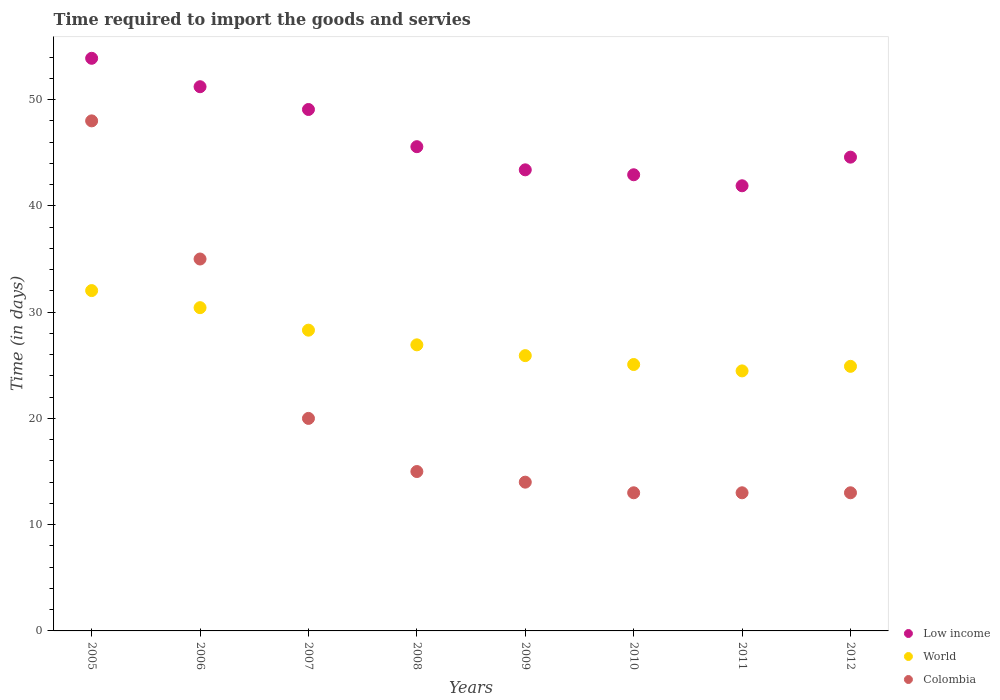Is the number of dotlines equal to the number of legend labels?
Give a very brief answer. Yes. What is the number of days required to import the goods and services in World in 2007?
Give a very brief answer. 28.3. Across all years, what is the maximum number of days required to import the goods and services in World?
Your response must be concise. 32.03. Across all years, what is the minimum number of days required to import the goods and services in Colombia?
Your answer should be compact. 13. In which year was the number of days required to import the goods and services in Colombia maximum?
Your answer should be compact. 2005. In which year was the number of days required to import the goods and services in Colombia minimum?
Make the answer very short. 2010. What is the total number of days required to import the goods and services in Colombia in the graph?
Provide a succinct answer. 171. What is the difference between the number of days required to import the goods and services in Low income in 2005 and that in 2006?
Offer a terse response. 2.67. What is the difference between the number of days required to import the goods and services in World in 2005 and the number of days required to import the goods and services in Colombia in 2008?
Your answer should be very brief. 17.03. What is the average number of days required to import the goods and services in World per year?
Ensure brevity in your answer.  27.25. In the year 2010, what is the difference between the number of days required to import the goods and services in Colombia and number of days required to import the goods and services in Low income?
Your response must be concise. -29.93. In how many years, is the number of days required to import the goods and services in World greater than 30 days?
Offer a very short reply. 2. What is the ratio of the number of days required to import the goods and services in Low income in 2006 to that in 2010?
Your answer should be compact. 1.19. What is the difference between the highest and the lowest number of days required to import the goods and services in World?
Your answer should be compact. 7.56. In how many years, is the number of days required to import the goods and services in Colombia greater than the average number of days required to import the goods and services in Colombia taken over all years?
Offer a very short reply. 2. Is the sum of the number of days required to import the goods and services in Low income in 2008 and 2009 greater than the maximum number of days required to import the goods and services in Colombia across all years?
Your response must be concise. Yes. Is the number of days required to import the goods and services in Colombia strictly less than the number of days required to import the goods and services in Low income over the years?
Provide a succinct answer. Yes. What is the difference between two consecutive major ticks on the Y-axis?
Offer a very short reply. 10. Are the values on the major ticks of Y-axis written in scientific E-notation?
Keep it short and to the point. No. Does the graph contain grids?
Provide a short and direct response. No. How many legend labels are there?
Ensure brevity in your answer.  3. What is the title of the graph?
Provide a succinct answer. Time required to import the goods and servies. What is the label or title of the Y-axis?
Offer a very short reply. Time (in days). What is the Time (in days) of Low income in 2005?
Make the answer very short. 53.89. What is the Time (in days) of World in 2005?
Provide a short and direct response. 32.03. What is the Time (in days) of Low income in 2006?
Ensure brevity in your answer.  51.21. What is the Time (in days) in World in 2006?
Offer a very short reply. 30.42. What is the Time (in days) of Colombia in 2006?
Provide a short and direct response. 35. What is the Time (in days) of Low income in 2007?
Provide a short and direct response. 49.07. What is the Time (in days) of World in 2007?
Your answer should be very brief. 28.3. What is the Time (in days) in Low income in 2008?
Provide a short and direct response. 45.57. What is the Time (in days) of World in 2008?
Provide a short and direct response. 26.92. What is the Time (in days) in Low income in 2009?
Give a very brief answer. 43.39. What is the Time (in days) in World in 2009?
Give a very brief answer. 25.91. What is the Time (in days) in Colombia in 2009?
Offer a terse response. 14. What is the Time (in days) of Low income in 2010?
Provide a succinct answer. 42.93. What is the Time (in days) of World in 2010?
Your answer should be very brief. 25.07. What is the Time (in days) of Colombia in 2010?
Provide a succinct answer. 13. What is the Time (in days) in Low income in 2011?
Offer a terse response. 41.89. What is the Time (in days) in World in 2011?
Give a very brief answer. 24.47. What is the Time (in days) in Low income in 2012?
Your answer should be very brief. 44.59. What is the Time (in days) of World in 2012?
Provide a succinct answer. 24.9. Across all years, what is the maximum Time (in days) of Low income?
Keep it short and to the point. 53.89. Across all years, what is the maximum Time (in days) of World?
Give a very brief answer. 32.03. Across all years, what is the minimum Time (in days) of Low income?
Keep it short and to the point. 41.89. Across all years, what is the minimum Time (in days) of World?
Your answer should be very brief. 24.47. What is the total Time (in days) in Low income in the graph?
Offer a very short reply. 372.55. What is the total Time (in days) in World in the graph?
Your answer should be very brief. 218.02. What is the total Time (in days) of Colombia in the graph?
Provide a short and direct response. 171. What is the difference between the Time (in days) in Low income in 2005 and that in 2006?
Offer a terse response. 2.67. What is the difference between the Time (in days) of World in 2005 and that in 2006?
Provide a succinct answer. 1.61. What is the difference between the Time (in days) in Low income in 2005 and that in 2007?
Make the answer very short. 4.82. What is the difference between the Time (in days) in World in 2005 and that in 2007?
Your answer should be compact. 3.72. What is the difference between the Time (in days) of Colombia in 2005 and that in 2007?
Your answer should be very brief. 28. What is the difference between the Time (in days) in Low income in 2005 and that in 2008?
Your answer should be very brief. 8.32. What is the difference between the Time (in days) in World in 2005 and that in 2008?
Your response must be concise. 5.11. What is the difference between the Time (in days) in Low income in 2005 and that in 2009?
Your response must be concise. 10.5. What is the difference between the Time (in days) of World in 2005 and that in 2009?
Keep it short and to the point. 6.12. What is the difference between the Time (in days) in Colombia in 2005 and that in 2009?
Offer a terse response. 34. What is the difference between the Time (in days) in Low income in 2005 and that in 2010?
Make the answer very short. 10.96. What is the difference between the Time (in days) of World in 2005 and that in 2010?
Provide a short and direct response. 6.96. What is the difference between the Time (in days) in Colombia in 2005 and that in 2010?
Offer a very short reply. 35. What is the difference between the Time (in days) in Low income in 2005 and that in 2011?
Your answer should be compact. 12. What is the difference between the Time (in days) of World in 2005 and that in 2011?
Your answer should be very brief. 7.56. What is the difference between the Time (in days) in Colombia in 2005 and that in 2011?
Keep it short and to the point. 35. What is the difference between the Time (in days) in Low income in 2005 and that in 2012?
Ensure brevity in your answer.  9.3. What is the difference between the Time (in days) of World in 2005 and that in 2012?
Offer a terse response. 7.13. What is the difference between the Time (in days) of Colombia in 2005 and that in 2012?
Ensure brevity in your answer.  35. What is the difference between the Time (in days) in Low income in 2006 and that in 2007?
Give a very brief answer. 2.14. What is the difference between the Time (in days) of World in 2006 and that in 2007?
Provide a short and direct response. 2.12. What is the difference between the Time (in days) of Colombia in 2006 and that in 2007?
Provide a succinct answer. 15. What is the difference between the Time (in days) in Low income in 2006 and that in 2008?
Offer a terse response. 5.64. What is the difference between the Time (in days) in World in 2006 and that in 2008?
Give a very brief answer. 3.5. What is the difference between the Time (in days) of Colombia in 2006 and that in 2008?
Provide a succinct answer. 20. What is the difference between the Time (in days) of Low income in 2006 and that in 2009?
Your answer should be compact. 7.82. What is the difference between the Time (in days) in World in 2006 and that in 2009?
Provide a succinct answer. 4.51. What is the difference between the Time (in days) of Colombia in 2006 and that in 2009?
Provide a succinct answer. 21. What is the difference between the Time (in days) in Low income in 2006 and that in 2010?
Ensure brevity in your answer.  8.29. What is the difference between the Time (in days) of World in 2006 and that in 2010?
Keep it short and to the point. 5.35. What is the difference between the Time (in days) of Low income in 2006 and that in 2011?
Give a very brief answer. 9.32. What is the difference between the Time (in days) in World in 2006 and that in 2011?
Give a very brief answer. 5.95. What is the difference between the Time (in days) in Low income in 2006 and that in 2012?
Your response must be concise. 6.63. What is the difference between the Time (in days) in World in 2006 and that in 2012?
Ensure brevity in your answer.  5.52. What is the difference between the Time (in days) of Colombia in 2006 and that in 2012?
Offer a very short reply. 22. What is the difference between the Time (in days) of Low income in 2007 and that in 2008?
Your response must be concise. 3.5. What is the difference between the Time (in days) of World in 2007 and that in 2008?
Your answer should be very brief. 1.38. What is the difference between the Time (in days) in Colombia in 2007 and that in 2008?
Your response must be concise. 5. What is the difference between the Time (in days) in Low income in 2007 and that in 2009?
Keep it short and to the point. 5.68. What is the difference between the Time (in days) of World in 2007 and that in 2009?
Provide a succinct answer. 2.4. What is the difference between the Time (in days) of Colombia in 2007 and that in 2009?
Provide a succinct answer. 6. What is the difference between the Time (in days) of Low income in 2007 and that in 2010?
Keep it short and to the point. 6.14. What is the difference between the Time (in days) in World in 2007 and that in 2010?
Your answer should be very brief. 3.23. What is the difference between the Time (in days) of Low income in 2007 and that in 2011?
Provide a short and direct response. 7.18. What is the difference between the Time (in days) in World in 2007 and that in 2011?
Your response must be concise. 3.83. What is the difference between the Time (in days) in Low income in 2007 and that in 2012?
Ensure brevity in your answer.  4.49. What is the difference between the Time (in days) of World in 2007 and that in 2012?
Ensure brevity in your answer.  3.4. What is the difference between the Time (in days) in Colombia in 2007 and that in 2012?
Your response must be concise. 7. What is the difference between the Time (in days) of Low income in 2008 and that in 2009?
Keep it short and to the point. 2.18. What is the difference between the Time (in days) in World in 2008 and that in 2009?
Provide a succinct answer. 1.02. What is the difference between the Time (in days) in Colombia in 2008 and that in 2009?
Provide a succinct answer. 1. What is the difference between the Time (in days) of Low income in 2008 and that in 2010?
Offer a terse response. 2.64. What is the difference between the Time (in days) in World in 2008 and that in 2010?
Your answer should be very brief. 1.85. What is the difference between the Time (in days) in Low income in 2008 and that in 2011?
Offer a very short reply. 3.68. What is the difference between the Time (in days) in World in 2008 and that in 2011?
Ensure brevity in your answer.  2.45. What is the difference between the Time (in days) in Colombia in 2008 and that in 2011?
Your answer should be very brief. 2. What is the difference between the Time (in days) of Low income in 2008 and that in 2012?
Ensure brevity in your answer.  0.99. What is the difference between the Time (in days) in World in 2008 and that in 2012?
Keep it short and to the point. 2.02. What is the difference between the Time (in days) in Colombia in 2008 and that in 2012?
Give a very brief answer. 2. What is the difference between the Time (in days) of Low income in 2009 and that in 2010?
Your response must be concise. 0.46. What is the difference between the Time (in days) of World in 2009 and that in 2010?
Your answer should be very brief. 0.84. What is the difference between the Time (in days) of Colombia in 2009 and that in 2010?
Keep it short and to the point. 1. What is the difference between the Time (in days) in World in 2009 and that in 2011?
Your response must be concise. 1.44. What is the difference between the Time (in days) in Colombia in 2009 and that in 2011?
Offer a very short reply. 1. What is the difference between the Time (in days) in Low income in 2009 and that in 2012?
Provide a short and direct response. -1.19. What is the difference between the Time (in days) of World in 2009 and that in 2012?
Provide a succinct answer. 1.01. What is the difference between the Time (in days) of Low income in 2010 and that in 2011?
Provide a succinct answer. 1.04. What is the difference between the Time (in days) of World in 2010 and that in 2011?
Provide a short and direct response. 0.6. What is the difference between the Time (in days) of Colombia in 2010 and that in 2011?
Offer a very short reply. 0. What is the difference between the Time (in days) of Low income in 2010 and that in 2012?
Give a very brief answer. -1.66. What is the difference between the Time (in days) in World in 2010 and that in 2012?
Offer a terse response. 0.17. What is the difference between the Time (in days) in Low income in 2011 and that in 2012?
Ensure brevity in your answer.  -2.69. What is the difference between the Time (in days) of World in 2011 and that in 2012?
Your response must be concise. -0.43. What is the difference between the Time (in days) in Colombia in 2011 and that in 2012?
Provide a short and direct response. 0. What is the difference between the Time (in days) of Low income in 2005 and the Time (in days) of World in 2006?
Your answer should be compact. 23.47. What is the difference between the Time (in days) in Low income in 2005 and the Time (in days) in Colombia in 2006?
Give a very brief answer. 18.89. What is the difference between the Time (in days) of World in 2005 and the Time (in days) of Colombia in 2006?
Give a very brief answer. -2.97. What is the difference between the Time (in days) of Low income in 2005 and the Time (in days) of World in 2007?
Give a very brief answer. 25.59. What is the difference between the Time (in days) in Low income in 2005 and the Time (in days) in Colombia in 2007?
Make the answer very short. 33.89. What is the difference between the Time (in days) in World in 2005 and the Time (in days) in Colombia in 2007?
Ensure brevity in your answer.  12.03. What is the difference between the Time (in days) of Low income in 2005 and the Time (in days) of World in 2008?
Offer a terse response. 26.97. What is the difference between the Time (in days) of Low income in 2005 and the Time (in days) of Colombia in 2008?
Offer a very short reply. 38.89. What is the difference between the Time (in days) in World in 2005 and the Time (in days) in Colombia in 2008?
Keep it short and to the point. 17.03. What is the difference between the Time (in days) of Low income in 2005 and the Time (in days) of World in 2009?
Your response must be concise. 27.98. What is the difference between the Time (in days) of Low income in 2005 and the Time (in days) of Colombia in 2009?
Your response must be concise. 39.89. What is the difference between the Time (in days) of World in 2005 and the Time (in days) of Colombia in 2009?
Offer a very short reply. 18.03. What is the difference between the Time (in days) in Low income in 2005 and the Time (in days) in World in 2010?
Provide a succinct answer. 28.82. What is the difference between the Time (in days) in Low income in 2005 and the Time (in days) in Colombia in 2010?
Give a very brief answer. 40.89. What is the difference between the Time (in days) in World in 2005 and the Time (in days) in Colombia in 2010?
Offer a very short reply. 19.03. What is the difference between the Time (in days) in Low income in 2005 and the Time (in days) in World in 2011?
Provide a succinct answer. 29.42. What is the difference between the Time (in days) of Low income in 2005 and the Time (in days) of Colombia in 2011?
Offer a terse response. 40.89. What is the difference between the Time (in days) in World in 2005 and the Time (in days) in Colombia in 2011?
Offer a very short reply. 19.03. What is the difference between the Time (in days) of Low income in 2005 and the Time (in days) of World in 2012?
Give a very brief answer. 28.99. What is the difference between the Time (in days) in Low income in 2005 and the Time (in days) in Colombia in 2012?
Provide a succinct answer. 40.89. What is the difference between the Time (in days) in World in 2005 and the Time (in days) in Colombia in 2012?
Keep it short and to the point. 19.03. What is the difference between the Time (in days) in Low income in 2006 and the Time (in days) in World in 2007?
Your answer should be very brief. 22.91. What is the difference between the Time (in days) in Low income in 2006 and the Time (in days) in Colombia in 2007?
Provide a succinct answer. 31.21. What is the difference between the Time (in days) of World in 2006 and the Time (in days) of Colombia in 2007?
Provide a short and direct response. 10.42. What is the difference between the Time (in days) in Low income in 2006 and the Time (in days) in World in 2008?
Your response must be concise. 24.29. What is the difference between the Time (in days) of Low income in 2006 and the Time (in days) of Colombia in 2008?
Offer a terse response. 36.21. What is the difference between the Time (in days) of World in 2006 and the Time (in days) of Colombia in 2008?
Offer a very short reply. 15.42. What is the difference between the Time (in days) in Low income in 2006 and the Time (in days) in World in 2009?
Provide a short and direct response. 25.31. What is the difference between the Time (in days) of Low income in 2006 and the Time (in days) of Colombia in 2009?
Provide a succinct answer. 37.21. What is the difference between the Time (in days) in World in 2006 and the Time (in days) in Colombia in 2009?
Your answer should be compact. 16.42. What is the difference between the Time (in days) of Low income in 2006 and the Time (in days) of World in 2010?
Provide a short and direct response. 26.14. What is the difference between the Time (in days) of Low income in 2006 and the Time (in days) of Colombia in 2010?
Make the answer very short. 38.21. What is the difference between the Time (in days) in World in 2006 and the Time (in days) in Colombia in 2010?
Provide a succinct answer. 17.42. What is the difference between the Time (in days) of Low income in 2006 and the Time (in days) of World in 2011?
Your response must be concise. 26.74. What is the difference between the Time (in days) of Low income in 2006 and the Time (in days) of Colombia in 2011?
Give a very brief answer. 38.21. What is the difference between the Time (in days) of World in 2006 and the Time (in days) of Colombia in 2011?
Your answer should be very brief. 17.42. What is the difference between the Time (in days) in Low income in 2006 and the Time (in days) in World in 2012?
Provide a short and direct response. 26.31. What is the difference between the Time (in days) of Low income in 2006 and the Time (in days) of Colombia in 2012?
Offer a very short reply. 38.21. What is the difference between the Time (in days) in World in 2006 and the Time (in days) in Colombia in 2012?
Your response must be concise. 17.42. What is the difference between the Time (in days) of Low income in 2007 and the Time (in days) of World in 2008?
Ensure brevity in your answer.  22.15. What is the difference between the Time (in days) of Low income in 2007 and the Time (in days) of Colombia in 2008?
Give a very brief answer. 34.07. What is the difference between the Time (in days) in World in 2007 and the Time (in days) in Colombia in 2008?
Offer a terse response. 13.3. What is the difference between the Time (in days) of Low income in 2007 and the Time (in days) of World in 2009?
Keep it short and to the point. 23.16. What is the difference between the Time (in days) of Low income in 2007 and the Time (in days) of Colombia in 2009?
Ensure brevity in your answer.  35.07. What is the difference between the Time (in days) of World in 2007 and the Time (in days) of Colombia in 2009?
Ensure brevity in your answer.  14.3. What is the difference between the Time (in days) in Low income in 2007 and the Time (in days) in World in 2010?
Ensure brevity in your answer.  24. What is the difference between the Time (in days) in Low income in 2007 and the Time (in days) in Colombia in 2010?
Make the answer very short. 36.07. What is the difference between the Time (in days) of World in 2007 and the Time (in days) of Colombia in 2010?
Keep it short and to the point. 15.3. What is the difference between the Time (in days) of Low income in 2007 and the Time (in days) of World in 2011?
Provide a short and direct response. 24.6. What is the difference between the Time (in days) of Low income in 2007 and the Time (in days) of Colombia in 2011?
Your response must be concise. 36.07. What is the difference between the Time (in days) in World in 2007 and the Time (in days) in Colombia in 2011?
Your answer should be compact. 15.3. What is the difference between the Time (in days) of Low income in 2007 and the Time (in days) of World in 2012?
Make the answer very short. 24.17. What is the difference between the Time (in days) of Low income in 2007 and the Time (in days) of Colombia in 2012?
Your response must be concise. 36.07. What is the difference between the Time (in days) in World in 2007 and the Time (in days) in Colombia in 2012?
Provide a succinct answer. 15.3. What is the difference between the Time (in days) in Low income in 2008 and the Time (in days) in World in 2009?
Keep it short and to the point. 19.66. What is the difference between the Time (in days) in Low income in 2008 and the Time (in days) in Colombia in 2009?
Keep it short and to the point. 31.57. What is the difference between the Time (in days) in World in 2008 and the Time (in days) in Colombia in 2009?
Give a very brief answer. 12.92. What is the difference between the Time (in days) in Low income in 2008 and the Time (in days) in World in 2010?
Provide a succinct answer. 20.5. What is the difference between the Time (in days) of Low income in 2008 and the Time (in days) of Colombia in 2010?
Your answer should be compact. 32.57. What is the difference between the Time (in days) in World in 2008 and the Time (in days) in Colombia in 2010?
Ensure brevity in your answer.  13.92. What is the difference between the Time (in days) in Low income in 2008 and the Time (in days) in World in 2011?
Provide a short and direct response. 21.1. What is the difference between the Time (in days) in Low income in 2008 and the Time (in days) in Colombia in 2011?
Ensure brevity in your answer.  32.57. What is the difference between the Time (in days) of World in 2008 and the Time (in days) of Colombia in 2011?
Ensure brevity in your answer.  13.92. What is the difference between the Time (in days) of Low income in 2008 and the Time (in days) of World in 2012?
Offer a very short reply. 20.67. What is the difference between the Time (in days) of Low income in 2008 and the Time (in days) of Colombia in 2012?
Your answer should be compact. 32.57. What is the difference between the Time (in days) in World in 2008 and the Time (in days) in Colombia in 2012?
Offer a very short reply. 13.92. What is the difference between the Time (in days) in Low income in 2009 and the Time (in days) in World in 2010?
Make the answer very short. 18.32. What is the difference between the Time (in days) of Low income in 2009 and the Time (in days) of Colombia in 2010?
Offer a very short reply. 30.39. What is the difference between the Time (in days) in World in 2009 and the Time (in days) in Colombia in 2010?
Your answer should be compact. 12.91. What is the difference between the Time (in days) in Low income in 2009 and the Time (in days) in World in 2011?
Ensure brevity in your answer.  18.92. What is the difference between the Time (in days) of Low income in 2009 and the Time (in days) of Colombia in 2011?
Your answer should be very brief. 30.39. What is the difference between the Time (in days) of World in 2009 and the Time (in days) of Colombia in 2011?
Your response must be concise. 12.91. What is the difference between the Time (in days) in Low income in 2009 and the Time (in days) in World in 2012?
Ensure brevity in your answer.  18.49. What is the difference between the Time (in days) in Low income in 2009 and the Time (in days) in Colombia in 2012?
Provide a short and direct response. 30.39. What is the difference between the Time (in days) of World in 2009 and the Time (in days) of Colombia in 2012?
Keep it short and to the point. 12.91. What is the difference between the Time (in days) in Low income in 2010 and the Time (in days) in World in 2011?
Offer a very short reply. 18.46. What is the difference between the Time (in days) of Low income in 2010 and the Time (in days) of Colombia in 2011?
Provide a short and direct response. 29.93. What is the difference between the Time (in days) in World in 2010 and the Time (in days) in Colombia in 2011?
Make the answer very short. 12.07. What is the difference between the Time (in days) in Low income in 2010 and the Time (in days) in World in 2012?
Your answer should be compact. 18.03. What is the difference between the Time (in days) in Low income in 2010 and the Time (in days) in Colombia in 2012?
Your response must be concise. 29.93. What is the difference between the Time (in days) in World in 2010 and the Time (in days) in Colombia in 2012?
Your answer should be very brief. 12.07. What is the difference between the Time (in days) of Low income in 2011 and the Time (in days) of World in 2012?
Offer a very short reply. 16.99. What is the difference between the Time (in days) of Low income in 2011 and the Time (in days) of Colombia in 2012?
Keep it short and to the point. 28.89. What is the difference between the Time (in days) in World in 2011 and the Time (in days) in Colombia in 2012?
Your response must be concise. 11.47. What is the average Time (in days) of Low income per year?
Provide a succinct answer. 46.57. What is the average Time (in days) in World per year?
Keep it short and to the point. 27.25. What is the average Time (in days) of Colombia per year?
Your answer should be very brief. 21.38. In the year 2005, what is the difference between the Time (in days) in Low income and Time (in days) in World?
Your answer should be very brief. 21.86. In the year 2005, what is the difference between the Time (in days) of Low income and Time (in days) of Colombia?
Your response must be concise. 5.89. In the year 2005, what is the difference between the Time (in days) in World and Time (in days) in Colombia?
Provide a succinct answer. -15.97. In the year 2006, what is the difference between the Time (in days) of Low income and Time (in days) of World?
Your response must be concise. 20.79. In the year 2006, what is the difference between the Time (in days) of Low income and Time (in days) of Colombia?
Provide a succinct answer. 16.21. In the year 2006, what is the difference between the Time (in days) in World and Time (in days) in Colombia?
Ensure brevity in your answer.  -4.58. In the year 2007, what is the difference between the Time (in days) in Low income and Time (in days) in World?
Your answer should be compact. 20.77. In the year 2007, what is the difference between the Time (in days) of Low income and Time (in days) of Colombia?
Make the answer very short. 29.07. In the year 2007, what is the difference between the Time (in days) in World and Time (in days) in Colombia?
Your answer should be very brief. 8.3. In the year 2008, what is the difference between the Time (in days) in Low income and Time (in days) in World?
Offer a terse response. 18.65. In the year 2008, what is the difference between the Time (in days) of Low income and Time (in days) of Colombia?
Offer a terse response. 30.57. In the year 2008, what is the difference between the Time (in days) of World and Time (in days) of Colombia?
Keep it short and to the point. 11.92. In the year 2009, what is the difference between the Time (in days) in Low income and Time (in days) in World?
Your answer should be very brief. 17.49. In the year 2009, what is the difference between the Time (in days) of Low income and Time (in days) of Colombia?
Ensure brevity in your answer.  29.39. In the year 2009, what is the difference between the Time (in days) in World and Time (in days) in Colombia?
Make the answer very short. 11.91. In the year 2010, what is the difference between the Time (in days) in Low income and Time (in days) in World?
Provide a short and direct response. 17.86. In the year 2010, what is the difference between the Time (in days) in Low income and Time (in days) in Colombia?
Your response must be concise. 29.93. In the year 2010, what is the difference between the Time (in days) in World and Time (in days) in Colombia?
Offer a terse response. 12.07. In the year 2011, what is the difference between the Time (in days) of Low income and Time (in days) of World?
Keep it short and to the point. 17.42. In the year 2011, what is the difference between the Time (in days) in Low income and Time (in days) in Colombia?
Provide a short and direct response. 28.89. In the year 2011, what is the difference between the Time (in days) of World and Time (in days) of Colombia?
Your answer should be compact. 11.47. In the year 2012, what is the difference between the Time (in days) of Low income and Time (in days) of World?
Your answer should be compact. 19.69. In the year 2012, what is the difference between the Time (in days) in Low income and Time (in days) in Colombia?
Your answer should be very brief. 31.59. In the year 2012, what is the difference between the Time (in days) in World and Time (in days) in Colombia?
Give a very brief answer. 11.9. What is the ratio of the Time (in days) in Low income in 2005 to that in 2006?
Your answer should be very brief. 1.05. What is the ratio of the Time (in days) in World in 2005 to that in 2006?
Your answer should be compact. 1.05. What is the ratio of the Time (in days) of Colombia in 2005 to that in 2006?
Offer a terse response. 1.37. What is the ratio of the Time (in days) of Low income in 2005 to that in 2007?
Provide a succinct answer. 1.1. What is the ratio of the Time (in days) of World in 2005 to that in 2007?
Offer a terse response. 1.13. What is the ratio of the Time (in days) of Colombia in 2005 to that in 2007?
Provide a succinct answer. 2.4. What is the ratio of the Time (in days) of Low income in 2005 to that in 2008?
Offer a terse response. 1.18. What is the ratio of the Time (in days) in World in 2005 to that in 2008?
Make the answer very short. 1.19. What is the ratio of the Time (in days) of Colombia in 2005 to that in 2008?
Ensure brevity in your answer.  3.2. What is the ratio of the Time (in days) of Low income in 2005 to that in 2009?
Offer a terse response. 1.24. What is the ratio of the Time (in days) of World in 2005 to that in 2009?
Offer a terse response. 1.24. What is the ratio of the Time (in days) of Colombia in 2005 to that in 2009?
Your response must be concise. 3.43. What is the ratio of the Time (in days) in Low income in 2005 to that in 2010?
Provide a short and direct response. 1.26. What is the ratio of the Time (in days) in World in 2005 to that in 2010?
Give a very brief answer. 1.28. What is the ratio of the Time (in days) of Colombia in 2005 to that in 2010?
Provide a short and direct response. 3.69. What is the ratio of the Time (in days) of Low income in 2005 to that in 2011?
Offer a very short reply. 1.29. What is the ratio of the Time (in days) in World in 2005 to that in 2011?
Give a very brief answer. 1.31. What is the ratio of the Time (in days) of Colombia in 2005 to that in 2011?
Ensure brevity in your answer.  3.69. What is the ratio of the Time (in days) of Low income in 2005 to that in 2012?
Your response must be concise. 1.21. What is the ratio of the Time (in days) of World in 2005 to that in 2012?
Keep it short and to the point. 1.29. What is the ratio of the Time (in days) in Colombia in 2005 to that in 2012?
Offer a very short reply. 3.69. What is the ratio of the Time (in days) of Low income in 2006 to that in 2007?
Your response must be concise. 1.04. What is the ratio of the Time (in days) in World in 2006 to that in 2007?
Keep it short and to the point. 1.07. What is the ratio of the Time (in days) in Colombia in 2006 to that in 2007?
Provide a succinct answer. 1.75. What is the ratio of the Time (in days) in Low income in 2006 to that in 2008?
Keep it short and to the point. 1.12. What is the ratio of the Time (in days) of World in 2006 to that in 2008?
Offer a terse response. 1.13. What is the ratio of the Time (in days) in Colombia in 2006 to that in 2008?
Offer a terse response. 2.33. What is the ratio of the Time (in days) in Low income in 2006 to that in 2009?
Provide a succinct answer. 1.18. What is the ratio of the Time (in days) of World in 2006 to that in 2009?
Your answer should be compact. 1.17. What is the ratio of the Time (in days) in Low income in 2006 to that in 2010?
Ensure brevity in your answer.  1.19. What is the ratio of the Time (in days) in World in 2006 to that in 2010?
Make the answer very short. 1.21. What is the ratio of the Time (in days) of Colombia in 2006 to that in 2010?
Provide a succinct answer. 2.69. What is the ratio of the Time (in days) of Low income in 2006 to that in 2011?
Your answer should be very brief. 1.22. What is the ratio of the Time (in days) of World in 2006 to that in 2011?
Offer a terse response. 1.24. What is the ratio of the Time (in days) in Colombia in 2006 to that in 2011?
Make the answer very short. 2.69. What is the ratio of the Time (in days) in Low income in 2006 to that in 2012?
Give a very brief answer. 1.15. What is the ratio of the Time (in days) of World in 2006 to that in 2012?
Give a very brief answer. 1.22. What is the ratio of the Time (in days) in Colombia in 2006 to that in 2012?
Provide a succinct answer. 2.69. What is the ratio of the Time (in days) in Low income in 2007 to that in 2008?
Your answer should be compact. 1.08. What is the ratio of the Time (in days) in World in 2007 to that in 2008?
Ensure brevity in your answer.  1.05. What is the ratio of the Time (in days) of Colombia in 2007 to that in 2008?
Keep it short and to the point. 1.33. What is the ratio of the Time (in days) of Low income in 2007 to that in 2009?
Keep it short and to the point. 1.13. What is the ratio of the Time (in days) of World in 2007 to that in 2009?
Keep it short and to the point. 1.09. What is the ratio of the Time (in days) of Colombia in 2007 to that in 2009?
Keep it short and to the point. 1.43. What is the ratio of the Time (in days) in Low income in 2007 to that in 2010?
Your answer should be very brief. 1.14. What is the ratio of the Time (in days) of World in 2007 to that in 2010?
Provide a succinct answer. 1.13. What is the ratio of the Time (in days) of Colombia in 2007 to that in 2010?
Make the answer very short. 1.54. What is the ratio of the Time (in days) in Low income in 2007 to that in 2011?
Keep it short and to the point. 1.17. What is the ratio of the Time (in days) of World in 2007 to that in 2011?
Offer a terse response. 1.16. What is the ratio of the Time (in days) in Colombia in 2007 to that in 2011?
Ensure brevity in your answer.  1.54. What is the ratio of the Time (in days) in Low income in 2007 to that in 2012?
Ensure brevity in your answer.  1.1. What is the ratio of the Time (in days) in World in 2007 to that in 2012?
Provide a succinct answer. 1.14. What is the ratio of the Time (in days) in Colombia in 2007 to that in 2012?
Make the answer very short. 1.54. What is the ratio of the Time (in days) in Low income in 2008 to that in 2009?
Keep it short and to the point. 1.05. What is the ratio of the Time (in days) in World in 2008 to that in 2009?
Keep it short and to the point. 1.04. What is the ratio of the Time (in days) of Colombia in 2008 to that in 2009?
Your answer should be very brief. 1.07. What is the ratio of the Time (in days) of Low income in 2008 to that in 2010?
Make the answer very short. 1.06. What is the ratio of the Time (in days) in World in 2008 to that in 2010?
Keep it short and to the point. 1.07. What is the ratio of the Time (in days) of Colombia in 2008 to that in 2010?
Your response must be concise. 1.15. What is the ratio of the Time (in days) of Low income in 2008 to that in 2011?
Your answer should be compact. 1.09. What is the ratio of the Time (in days) of World in 2008 to that in 2011?
Make the answer very short. 1.1. What is the ratio of the Time (in days) of Colombia in 2008 to that in 2011?
Keep it short and to the point. 1.15. What is the ratio of the Time (in days) of Low income in 2008 to that in 2012?
Your answer should be compact. 1.02. What is the ratio of the Time (in days) in World in 2008 to that in 2012?
Provide a succinct answer. 1.08. What is the ratio of the Time (in days) in Colombia in 2008 to that in 2012?
Provide a short and direct response. 1.15. What is the ratio of the Time (in days) of Low income in 2009 to that in 2010?
Your answer should be very brief. 1.01. What is the ratio of the Time (in days) in World in 2009 to that in 2010?
Your response must be concise. 1.03. What is the ratio of the Time (in days) of Colombia in 2009 to that in 2010?
Your response must be concise. 1.08. What is the ratio of the Time (in days) in Low income in 2009 to that in 2011?
Provide a succinct answer. 1.04. What is the ratio of the Time (in days) of World in 2009 to that in 2011?
Offer a terse response. 1.06. What is the ratio of the Time (in days) in Colombia in 2009 to that in 2011?
Provide a short and direct response. 1.08. What is the ratio of the Time (in days) of Low income in 2009 to that in 2012?
Provide a short and direct response. 0.97. What is the ratio of the Time (in days) in World in 2009 to that in 2012?
Your response must be concise. 1.04. What is the ratio of the Time (in days) of Colombia in 2009 to that in 2012?
Give a very brief answer. 1.08. What is the ratio of the Time (in days) in Low income in 2010 to that in 2011?
Your response must be concise. 1.02. What is the ratio of the Time (in days) of World in 2010 to that in 2011?
Give a very brief answer. 1.02. What is the ratio of the Time (in days) of Colombia in 2010 to that in 2011?
Your answer should be very brief. 1. What is the ratio of the Time (in days) in Low income in 2010 to that in 2012?
Offer a very short reply. 0.96. What is the ratio of the Time (in days) in Low income in 2011 to that in 2012?
Your answer should be very brief. 0.94. What is the ratio of the Time (in days) in World in 2011 to that in 2012?
Your response must be concise. 0.98. What is the difference between the highest and the second highest Time (in days) of Low income?
Provide a short and direct response. 2.67. What is the difference between the highest and the second highest Time (in days) in World?
Offer a very short reply. 1.61. What is the difference between the highest and the lowest Time (in days) of Low income?
Ensure brevity in your answer.  12. What is the difference between the highest and the lowest Time (in days) in World?
Offer a terse response. 7.56. What is the difference between the highest and the lowest Time (in days) of Colombia?
Your answer should be compact. 35. 